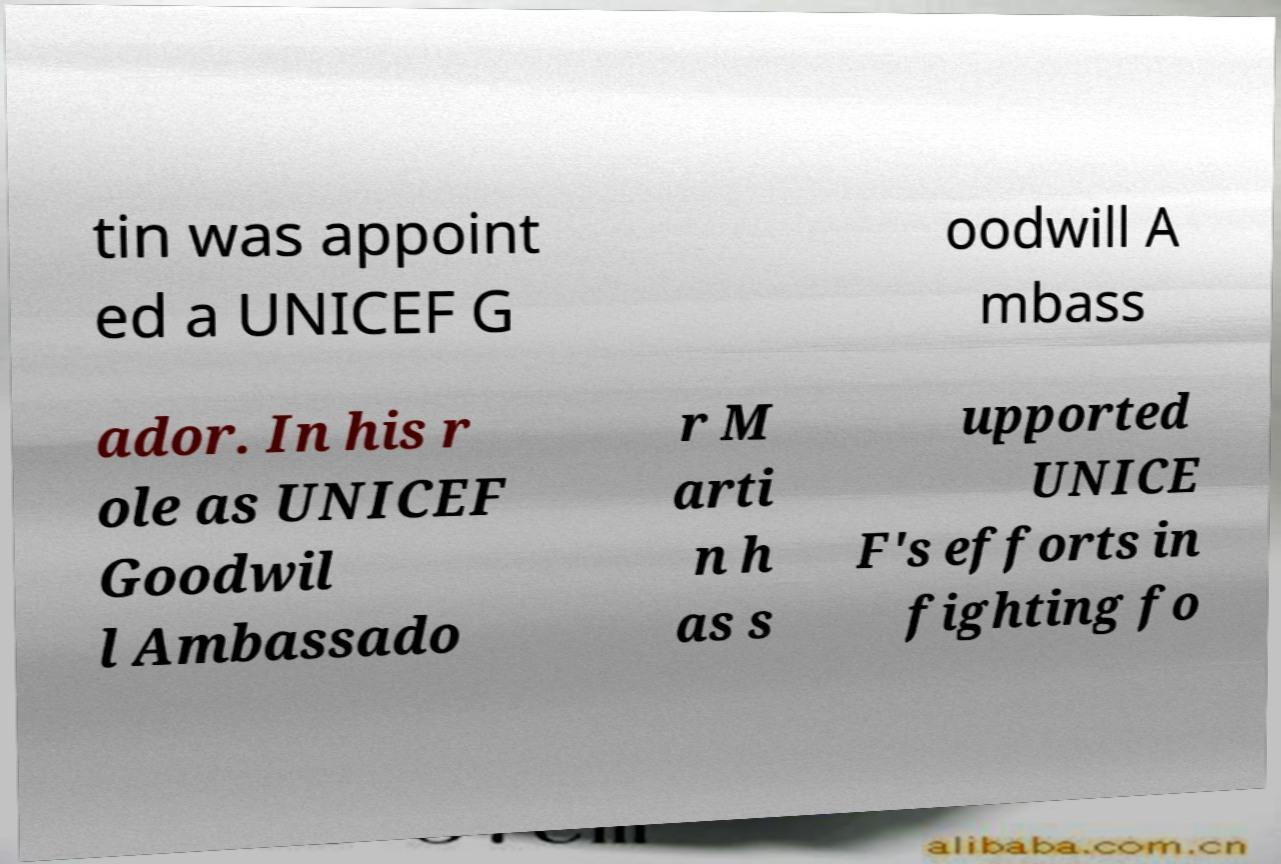I need the written content from this picture converted into text. Can you do that? tin was appoint ed a UNICEF G oodwill A mbass ador. In his r ole as UNICEF Goodwil l Ambassado r M arti n h as s upported UNICE F's efforts in fighting fo 